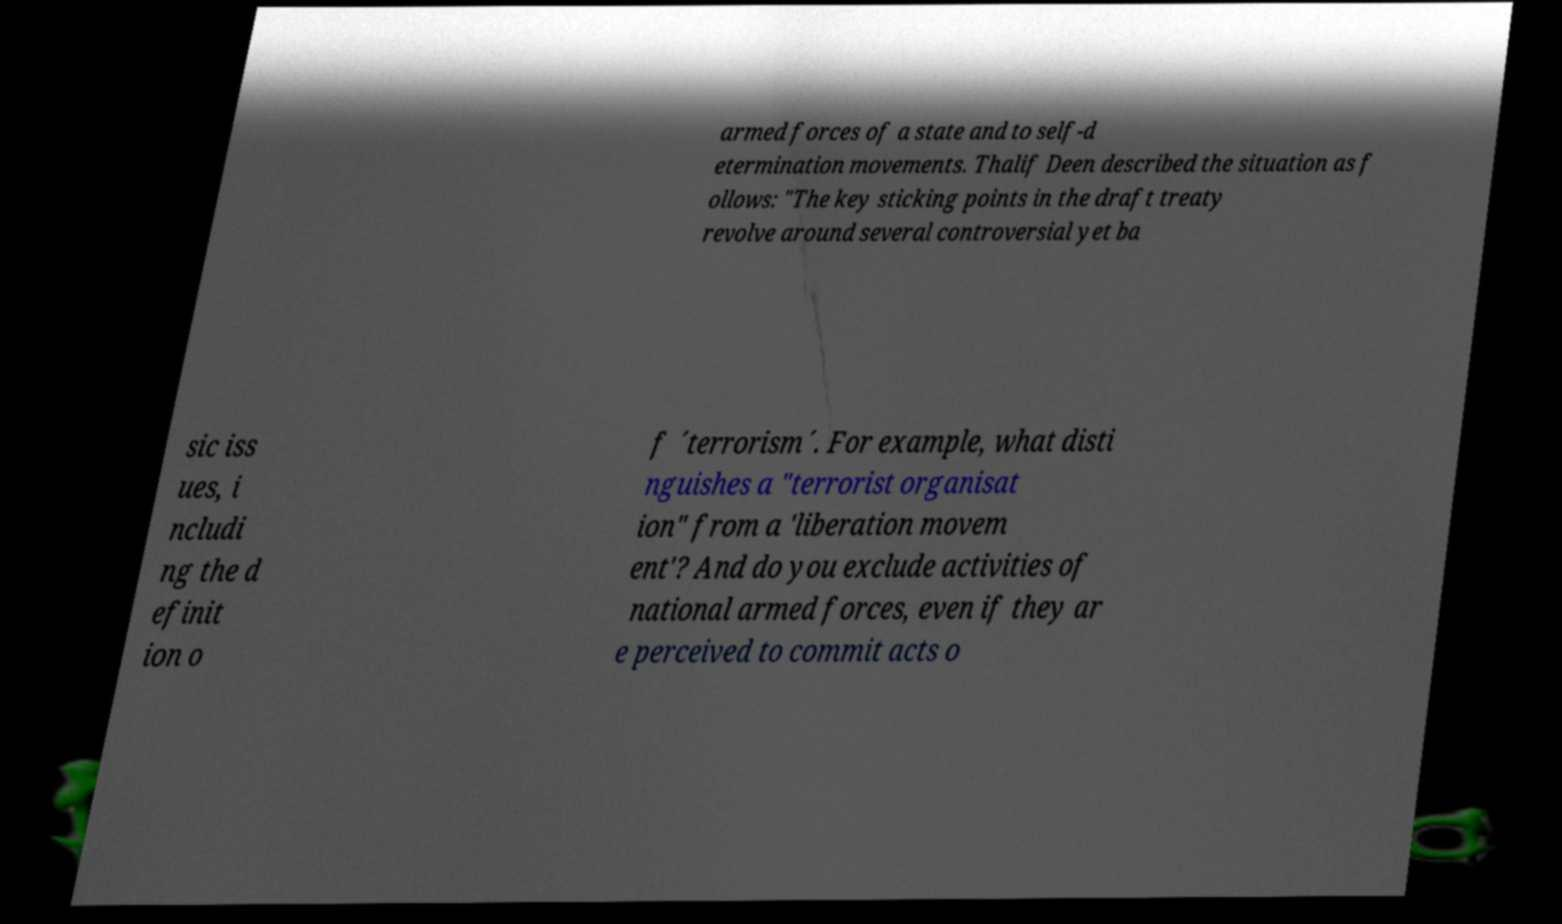Can you read and provide the text displayed in the image?This photo seems to have some interesting text. Can you extract and type it out for me? armed forces of a state and to self-d etermination movements. Thalif Deen described the situation as f ollows: "The key sticking points in the draft treaty revolve around several controversial yet ba sic iss ues, i ncludi ng the d efinit ion o f ´terrorism´. For example, what disti nguishes a "terrorist organisat ion" from a 'liberation movem ent'? And do you exclude activities of national armed forces, even if they ar e perceived to commit acts o 